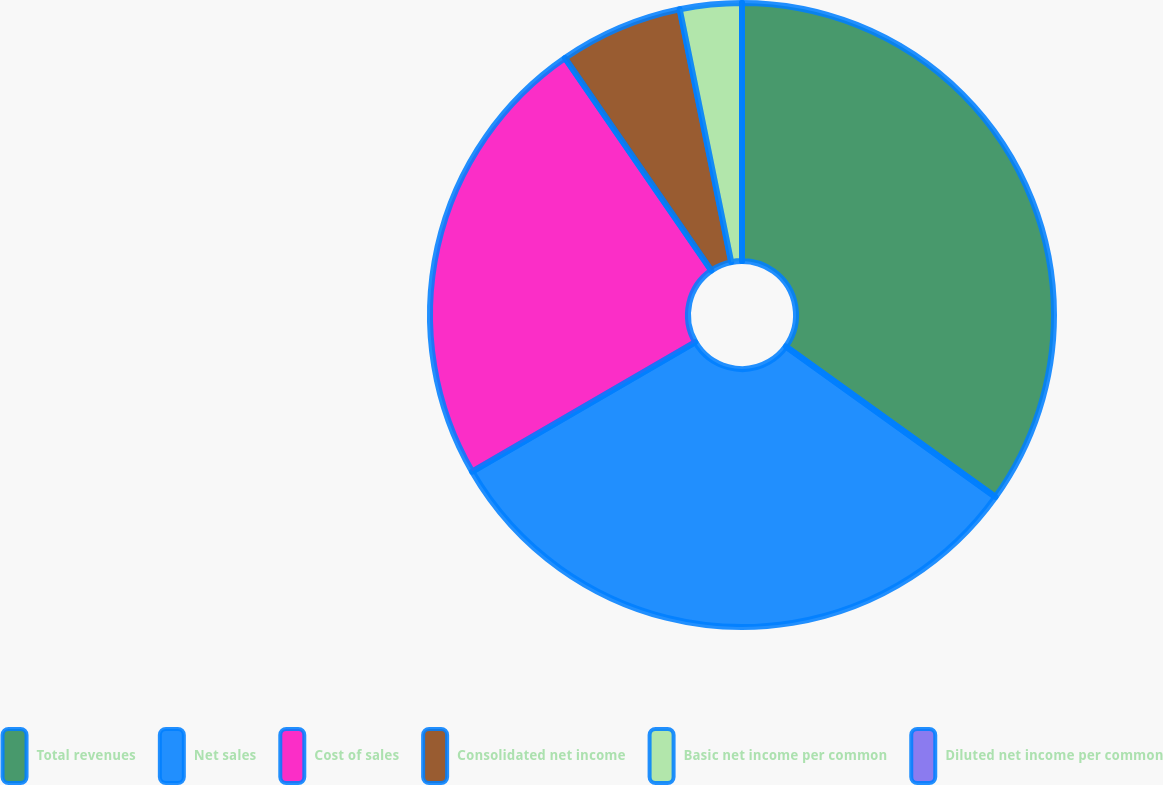<chart> <loc_0><loc_0><loc_500><loc_500><pie_chart><fcel>Total revenues<fcel>Net sales<fcel>Cost of sales<fcel>Consolidated net income<fcel>Basic net income per common<fcel>Diluted net income per common<nl><fcel>34.91%<fcel>31.72%<fcel>23.77%<fcel>6.4%<fcel>3.2%<fcel>0.0%<nl></chart> 